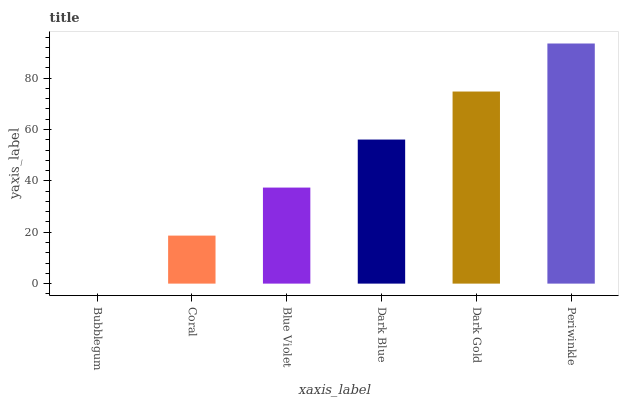Is Bubblegum the minimum?
Answer yes or no. Yes. Is Periwinkle the maximum?
Answer yes or no. Yes. Is Coral the minimum?
Answer yes or no. No. Is Coral the maximum?
Answer yes or no. No. Is Coral greater than Bubblegum?
Answer yes or no. Yes. Is Bubblegum less than Coral?
Answer yes or no. Yes. Is Bubblegum greater than Coral?
Answer yes or no. No. Is Coral less than Bubblegum?
Answer yes or no. No. Is Dark Blue the high median?
Answer yes or no. Yes. Is Blue Violet the low median?
Answer yes or no. Yes. Is Periwinkle the high median?
Answer yes or no. No. Is Periwinkle the low median?
Answer yes or no. No. 